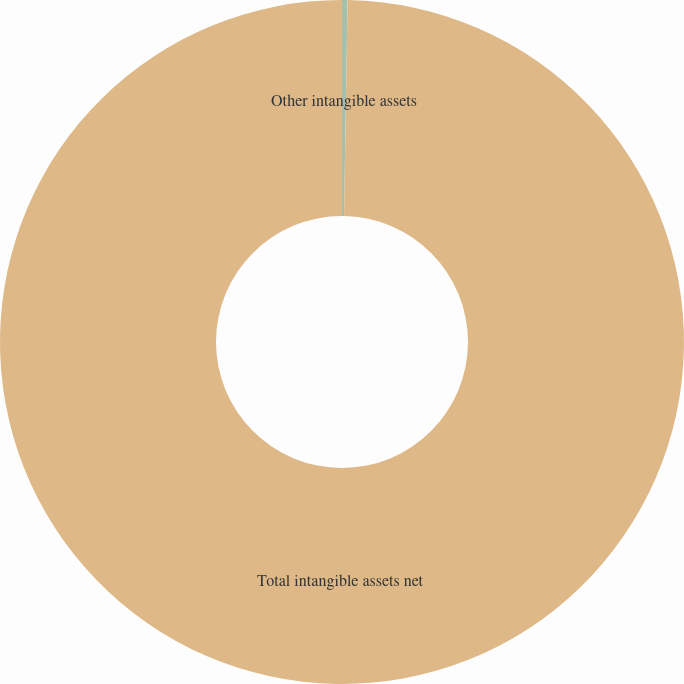Convert chart. <chart><loc_0><loc_0><loc_500><loc_500><pie_chart><fcel>Other intangible assets<fcel>Total intangible assets net<nl><fcel>0.26%<fcel>99.74%<nl></chart> 